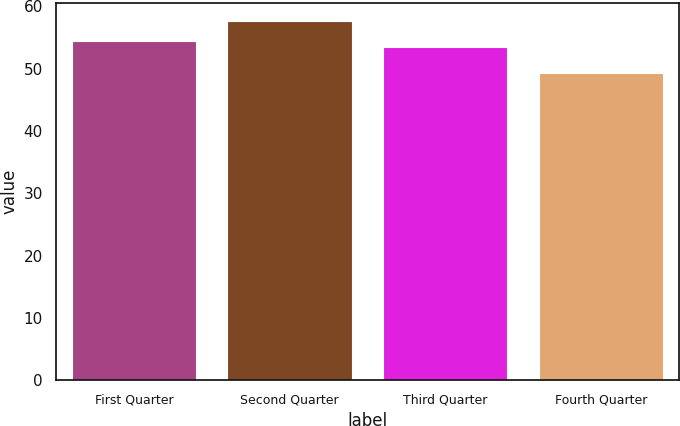<chart> <loc_0><loc_0><loc_500><loc_500><bar_chart><fcel>First Quarter<fcel>Second Quarter<fcel>Third Quarter<fcel>Fourth Quarter<nl><fcel>54.39<fcel>57.7<fcel>53.55<fcel>49.25<nl></chart> 